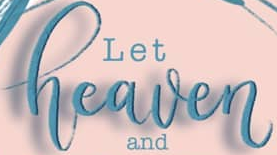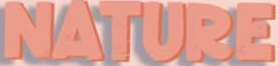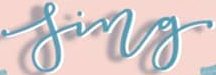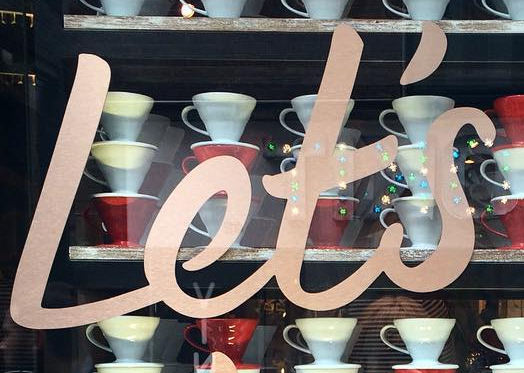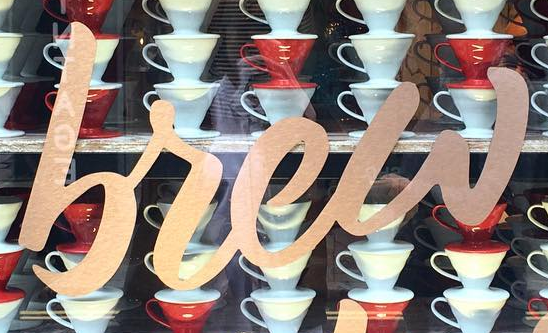Transcribe the words shown in these images in order, separated by a semicolon. heaven; NATURE; sing; Let's; brew 